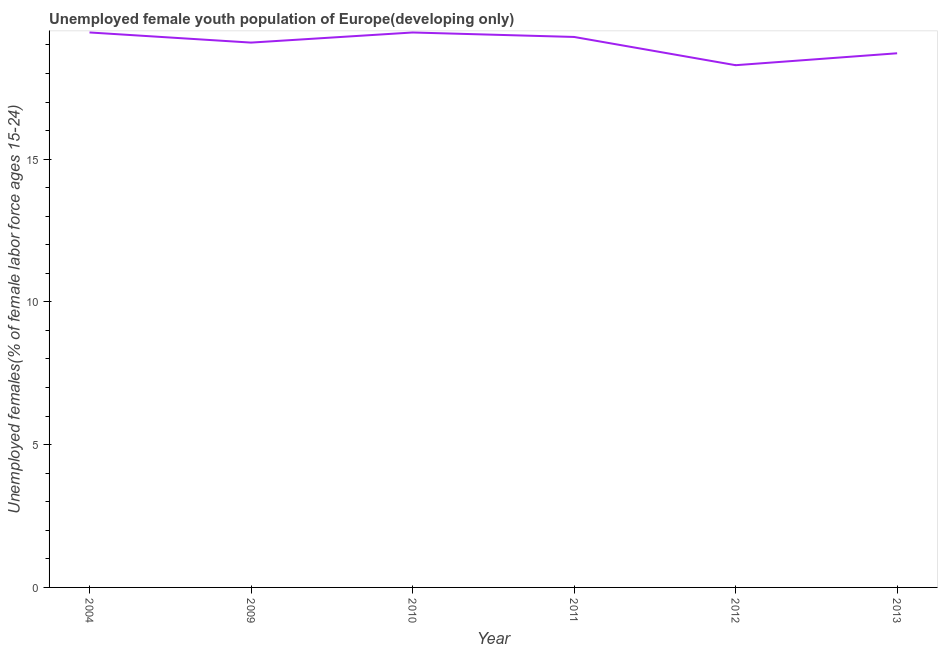What is the unemployed female youth in 2012?
Your answer should be compact. 18.29. Across all years, what is the maximum unemployed female youth?
Ensure brevity in your answer.  19.44. Across all years, what is the minimum unemployed female youth?
Offer a very short reply. 18.29. In which year was the unemployed female youth minimum?
Offer a very short reply. 2012. What is the sum of the unemployed female youth?
Your response must be concise. 114.23. What is the difference between the unemployed female youth in 2010 and 2011?
Keep it short and to the point. 0.16. What is the average unemployed female youth per year?
Provide a succinct answer. 19.04. What is the median unemployed female youth?
Make the answer very short. 19.18. Do a majority of the years between 2010 and 2004 (inclusive) have unemployed female youth greater than 4 %?
Your response must be concise. No. What is the ratio of the unemployed female youth in 2010 to that in 2012?
Your answer should be compact. 1.06. Is the unemployed female youth in 2010 less than that in 2013?
Provide a short and direct response. No. Is the difference between the unemployed female youth in 2009 and 2013 greater than the difference between any two years?
Offer a very short reply. No. What is the difference between the highest and the second highest unemployed female youth?
Your response must be concise. 0. What is the difference between the highest and the lowest unemployed female youth?
Your answer should be very brief. 1.15. Does the unemployed female youth monotonically increase over the years?
Your answer should be very brief. No. What is the difference between two consecutive major ticks on the Y-axis?
Offer a terse response. 5. Does the graph contain any zero values?
Keep it short and to the point. No. Does the graph contain grids?
Offer a terse response. No. What is the title of the graph?
Give a very brief answer. Unemployed female youth population of Europe(developing only). What is the label or title of the X-axis?
Offer a very short reply. Year. What is the label or title of the Y-axis?
Make the answer very short. Unemployed females(% of female labor force ages 15-24). What is the Unemployed females(% of female labor force ages 15-24) of 2004?
Your response must be concise. 19.44. What is the Unemployed females(% of female labor force ages 15-24) of 2009?
Your answer should be very brief. 19.08. What is the Unemployed females(% of female labor force ages 15-24) in 2010?
Your answer should be compact. 19.43. What is the Unemployed females(% of female labor force ages 15-24) in 2011?
Your answer should be very brief. 19.28. What is the Unemployed females(% of female labor force ages 15-24) of 2012?
Make the answer very short. 18.29. What is the Unemployed females(% of female labor force ages 15-24) in 2013?
Your response must be concise. 18.71. What is the difference between the Unemployed females(% of female labor force ages 15-24) in 2004 and 2009?
Give a very brief answer. 0.35. What is the difference between the Unemployed females(% of female labor force ages 15-24) in 2004 and 2010?
Your answer should be very brief. 0. What is the difference between the Unemployed females(% of female labor force ages 15-24) in 2004 and 2011?
Offer a very short reply. 0.16. What is the difference between the Unemployed females(% of female labor force ages 15-24) in 2004 and 2012?
Your answer should be compact. 1.15. What is the difference between the Unemployed females(% of female labor force ages 15-24) in 2004 and 2013?
Offer a terse response. 0.73. What is the difference between the Unemployed females(% of female labor force ages 15-24) in 2009 and 2010?
Ensure brevity in your answer.  -0.35. What is the difference between the Unemployed females(% of female labor force ages 15-24) in 2009 and 2011?
Offer a terse response. -0.2. What is the difference between the Unemployed females(% of female labor force ages 15-24) in 2009 and 2012?
Keep it short and to the point. 0.79. What is the difference between the Unemployed females(% of female labor force ages 15-24) in 2009 and 2013?
Your response must be concise. 0.37. What is the difference between the Unemployed females(% of female labor force ages 15-24) in 2010 and 2011?
Provide a succinct answer. 0.16. What is the difference between the Unemployed females(% of female labor force ages 15-24) in 2010 and 2012?
Your answer should be very brief. 1.15. What is the difference between the Unemployed females(% of female labor force ages 15-24) in 2010 and 2013?
Make the answer very short. 0.73. What is the difference between the Unemployed females(% of female labor force ages 15-24) in 2011 and 2012?
Give a very brief answer. 0.99. What is the difference between the Unemployed females(% of female labor force ages 15-24) in 2011 and 2013?
Your answer should be compact. 0.57. What is the difference between the Unemployed females(% of female labor force ages 15-24) in 2012 and 2013?
Ensure brevity in your answer.  -0.42. What is the ratio of the Unemployed females(% of female labor force ages 15-24) in 2004 to that in 2009?
Give a very brief answer. 1.02. What is the ratio of the Unemployed females(% of female labor force ages 15-24) in 2004 to that in 2012?
Ensure brevity in your answer.  1.06. What is the ratio of the Unemployed females(% of female labor force ages 15-24) in 2004 to that in 2013?
Offer a very short reply. 1.04. What is the ratio of the Unemployed females(% of female labor force ages 15-24) in 2009 to that in 2012?
Keep it short and to the point. 1.04. What is the ratio of the Unemployed females(% of female labor force ages 15-24) in 2010 to that in 2011?
Offer a terse response. 1.01. What is the ratio of the Unemployed females(% of female labor force ages 15-24) in 2010 to that in 2012?
Provide a succinct answer. 1.06. What is the ratio of the Unemployed females(% of female labor force ages 15-24) in 2010 to that in 2013?
Offer a very short reply. 1.04. What is the ratio of the Unemployed females(% of female labor force ages 15-24) in 2011 to that in 2012?
Ensure brevity in your answer.  1.05. What is the ratio of the Unemployed females(% of female labor force ages 15-24) in 2011 to that in 2013?
Keep it short and to the point. 1.03. 